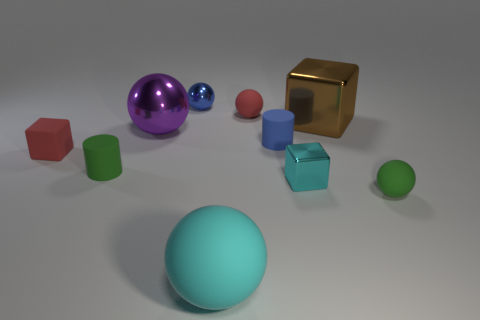Subtract 1 spheres. How many spheres are left? 4 Subtract all blue spheres. How many spheres are left? 4 Subtract all red spheres. How many spheres are left? 4 Subtract all yellow balls. Subtract all red cylinders. How many balls are left? 5 Subtract all cylinders. How many objects are left? 8 Add 2 small metallic spheres. How many small metallic spheres are left? 3 Add 2 tiny blue cylinders. How many tiny blue cylinders exist? 3 Subtract 0 green cubes. How many objects are left? 10 Subtract all shiny cubes. Subtract all big metal spheres. How many objects are left? 7 